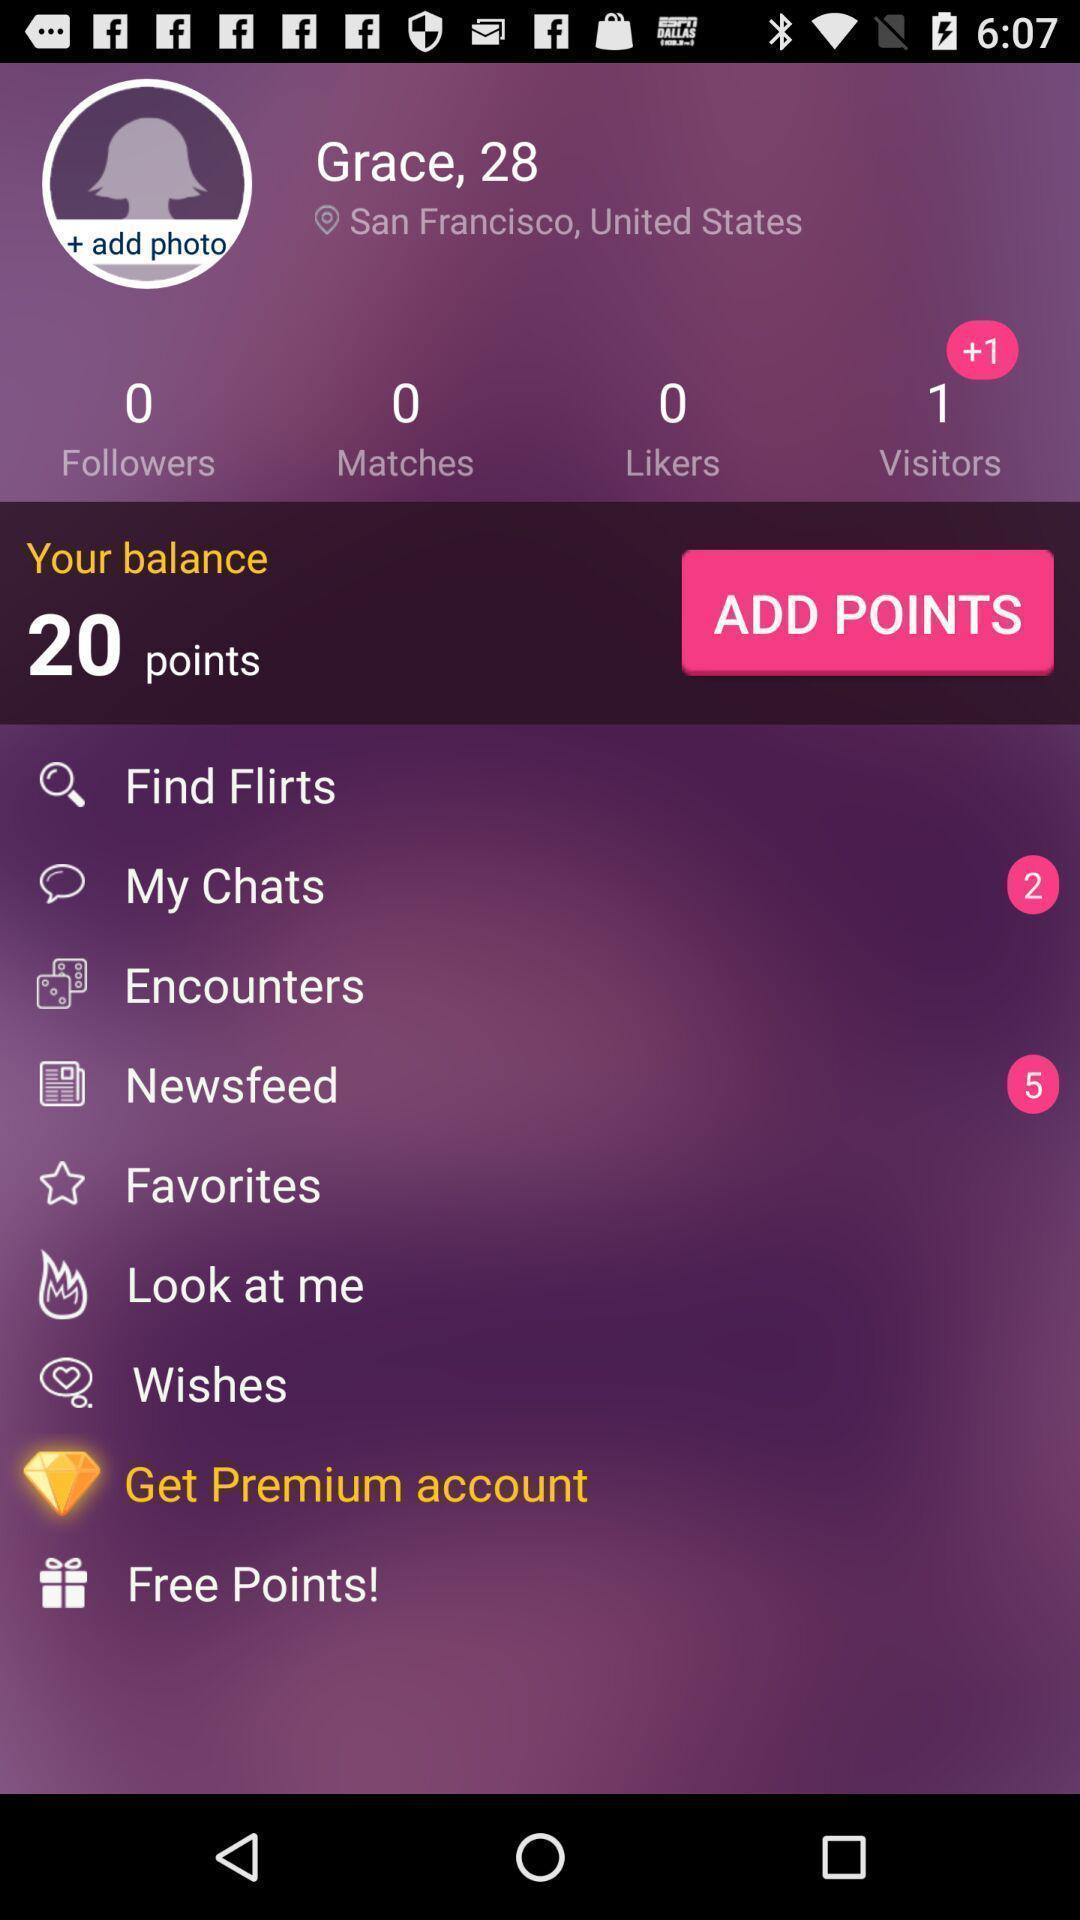Explain the elements present in this screenshot. Profile page of a social account. 